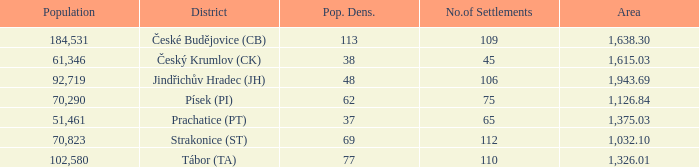What is the population with an area of 1,126.84? 70290.0. Can you parse all the data within this table? {'header': ['Population', 'District', 'Pop. Dens.', 'No.of Settlements', 'Area'], 'rows': [['184,531', 'České Budějovice (CB)', '113', '109', '1,638.30'], ['61,346', 'Český Krumlov (CK)', '38', '45', '1,615.03'], ['92,719', 'Jindřichův Hradec (JH)', '48', '106', '1,943.69'], ['70,290', 'Písek (PI)', '62', '75', '1,126.84'], ['51,461', 'Prachatice (PT)', '37', '65', '1,375.03'], ['70,823', 'Strakonice (ST)', '69', '112', '1,032.10'], ['102,580', 'Tábor (TA)', '77', '110', '1,326.01']]} 